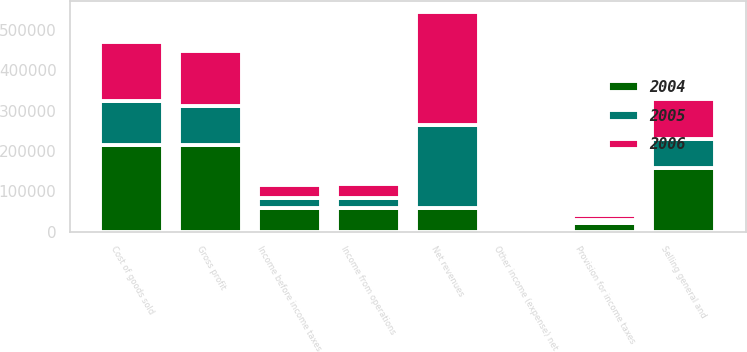Convert chart to OTSL. <chart><loc_0><loc_0><loc_500><loc_500><stacked_bar_chart><ecel><fcel>Net revenues<fcel>Cost of goods sold<fcel>Gross profit<fcel>Selling general and<fcel>Income from operations<fcel>Other income (expense) net<fcel>Income before income taxes<fcel>Provision for income taxes<nl><fcel>2004<fcel>59087<fcel>215089<fcel>215600<fcel>158323<fcel>57277<fcel>1810<fcel>59087<fcel>20108<nl><fcel>2006<fcel>281053<fcel>145203<fcel>135850<fcel>99961<fcel>35889<fcel>2915<fcel>32974<fcel>13255<nl><fcel>2005<fcel>205181<fcel>109748<fcel>95433<fcel>70053<fcel>25380<fcel>1284<fcel>24096<fcel>7774<nl></chart> 